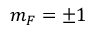Convert formula to latex. <formula><loc_0><loc_0><loc_500><loc_500>m _ { F } = \pm 1</formula> 